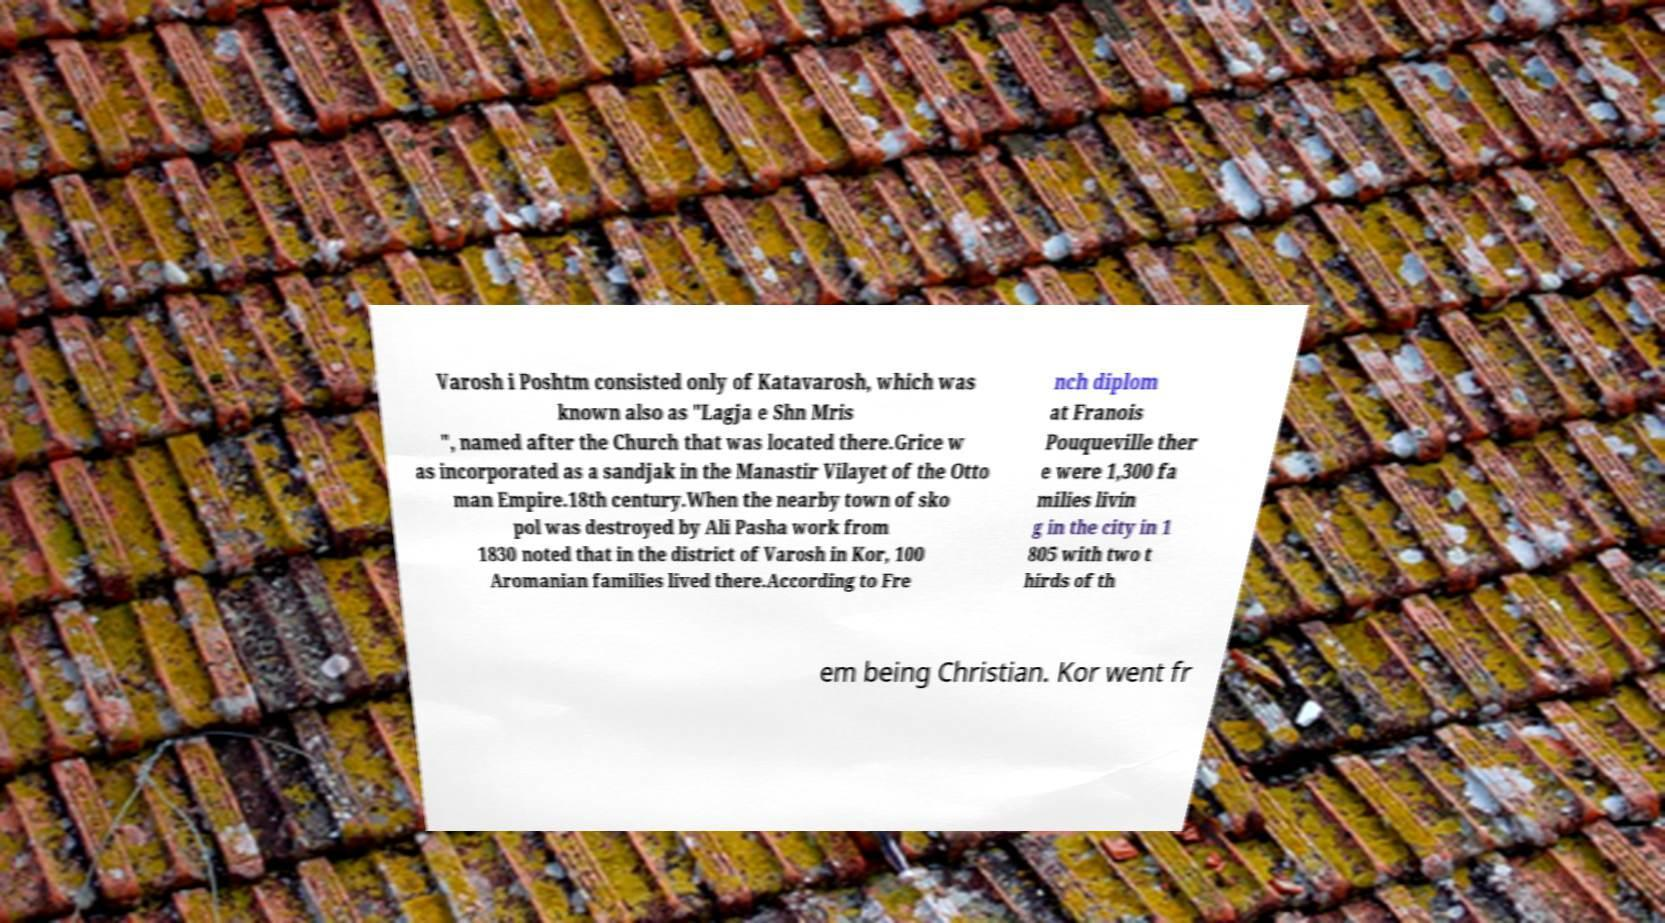Can you read and provide the text displayed in the image?This photo seems to have some interesting text. Can you extract and type it out for me? Varosh i Poshtm consisted only of Katavarosh, which was known also as "Lagja e Shn Mris ", named after the Church that was located there.Grice w as incorporated as a sandjak in the Manastir Vilayet of the Otto man Empire.18th century.When the nearby town of sko pol was destroyed by Ali Pasha work from 1830 noted that in the district of Varosh in Kor, 100 Aromanian families lived there.According to Fre nch diplom at Franois Pouqueville ther e were 1,300 fa milies livin g in the city in 1 805 with two t hirds of th em being Christian. Kor went fr 